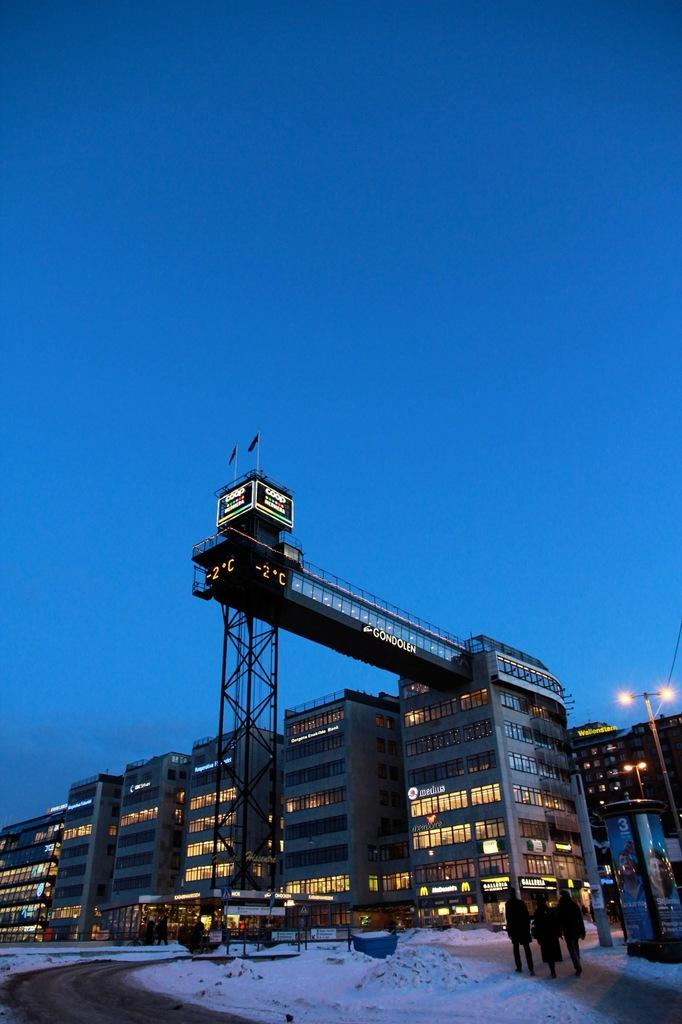What is happening in the foreground of the image? There is a group of people on the road in the foreground. What can be seen in the background of the image? The background of the image is covered by the sky. What type of structures are visible in the image? There are buildings visible in the image. What is the source of illumination in the image? Lights are present in the image. What type of base is supporting the tramp in the image? There is no tramp present in the image. What shape is the square in the image? There is no square present in the image. 